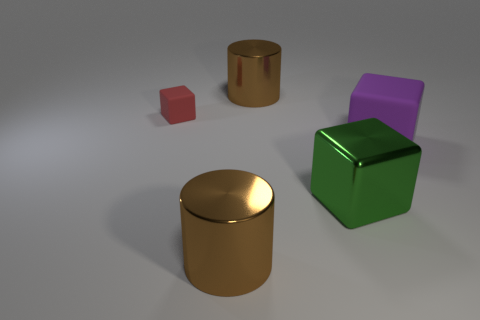Is the color of the big cylinder in front of the small matte block the same as the big metal thing behind the large green object?
Keep it short and to the point. Yes. Does the small thing have the same shape as the object that is on the right side of the big green cube?
Your answer should be very brief. Yes. There is a small thing that is made of the same material as the purple block; what shape is it?
Your response must be concise. Cube. Are there more large brown cylinders in front of the red rubber object than large purple matte things in front of the big purple object?
Give a very brief answer. Yes. What number of objects are either metal cubes or red cubes?
Give a very brief answer. 2. What number of other objects are the same color as the big metal block?
Ensure brevity in your answer.  0. What shape is the purple rubber object that is the same size as the green thing?
Provide a short and direct response. Cube. There is a matte object in front of the small red rubber thing; what is its color?
Make the answer very short. Purple. How many things are either objects that are left of the big green metal block or things to the left of the purple object?
Provide a short and direct response. 4. Do the purple matte block and the red object have the same size?
Offer a very short reply. No. 